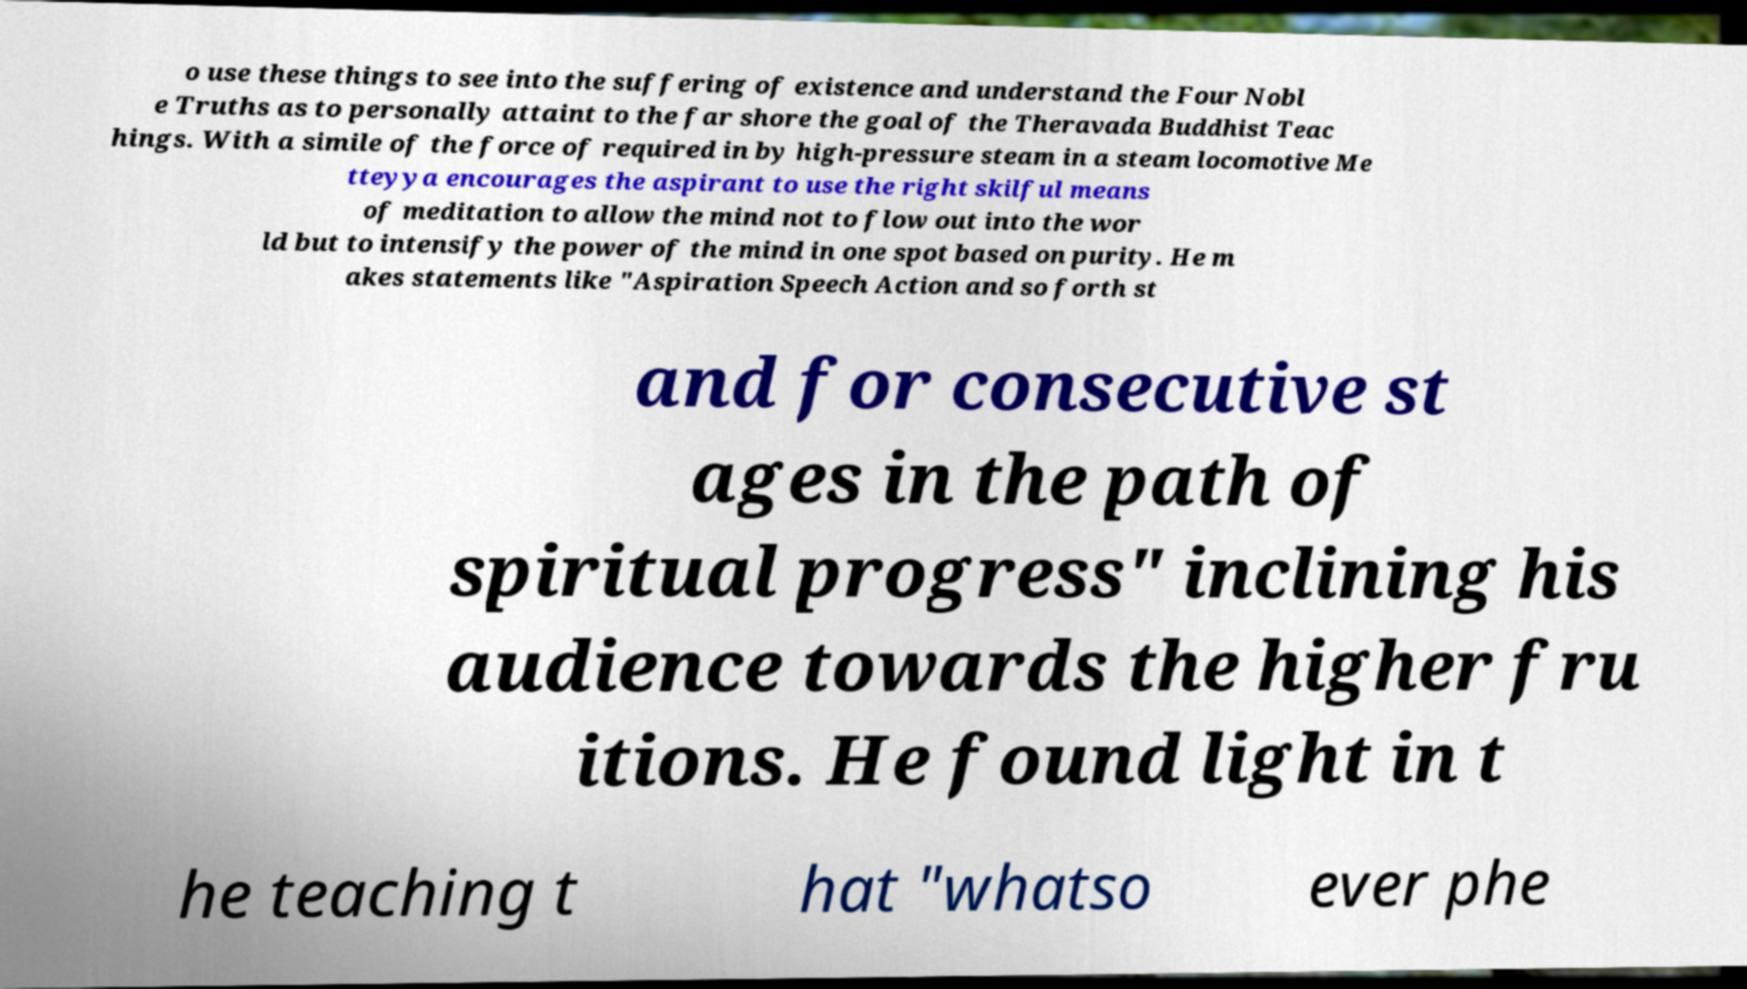For documentation purposes, I need the text within this image transcribed. Could you provide that? o use these things to see into the suffering of existence and understand the Four Nobl e Truths as to personally attaint to the far shore the goal of the Theravada Buddhist Teac hings. With a simile of the force of required in by high-pressure steam in a steam locomotive Me tteyya encourages the aspirant to use the right skilful means of meditation to allow the mind not to flow out into the wor ld but to intensify the power of the mind in one spot based on purity. He m akes statements like "Aspiration Speech Action and so forth st and for consecutive st ages in the path of spiritual progress" inclining his audience towards the higher fru itions. He found light in t he teaching t hat "whatso ever phe 